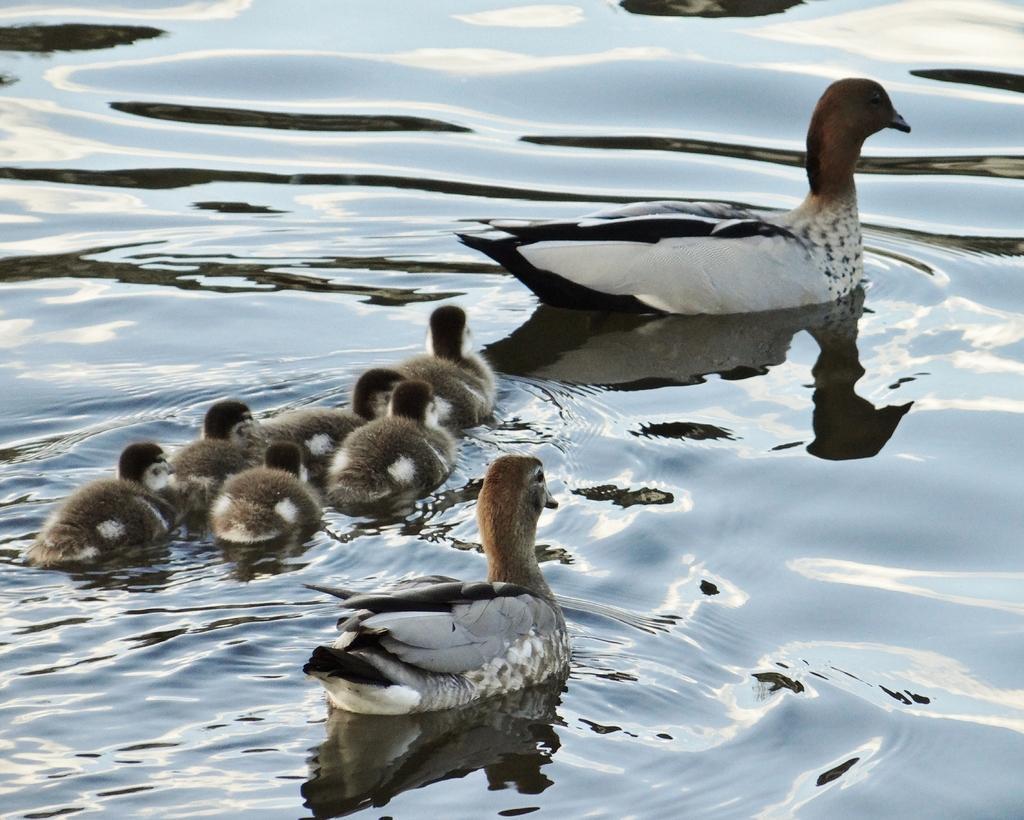Describe this image in one or two sentences. In this picture we can see ducks on the water. 